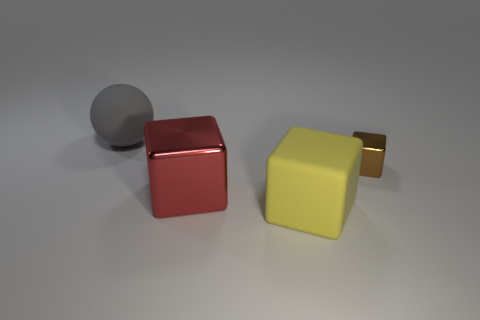Subtract all gray cubes. Subtract all purple cylinders. How many cubes are left? 3 Add 3 small brown metal things. How many objects exist? 7 Subtract all balls. How many objects are left? 3 Subtract 0 brown spheres. How many objects are left? 4 Subtract all large blue objects. Subtract all gray objects. How many objects are left? 3 Add 1 big yellow matte objects. How many big yellow matte objects are left? 2 Add 2 big yellow metallic blocks. How many big yellow metallic blocks exist? 2 